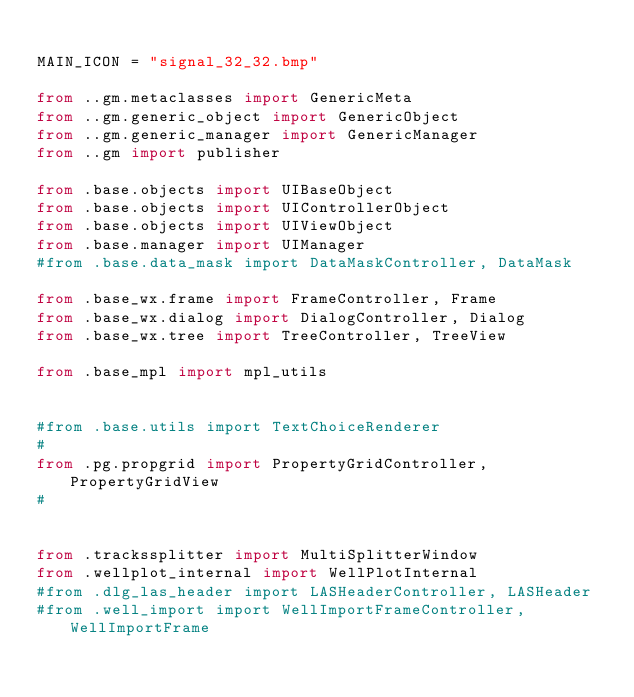<code> <loc_0><loc_0><loc_500><loc_500><_Python_>
MAIN_ICON = "signal_32_32.bmp"

from ..gm.metaclasses import GenericMeta
from ..gm.generic_object import GenericObject
from ..gm.generic_manager import GenericManager
from ..gm import publisher

from .base.objects import UIBaseObject
from .base.objects import UIControllerObject
from .base.objects import UIViewObject
from .base.manager import UIManager
#from .base.data_mask import DataMaskController, DataMask

from .base_wx.frame import FrameController, Frame
from .base_wx.dialog import DialogController, Dialog
from .base_wx.tree import TreeController, TreeView

from .base_mpl import mpl_utils
 

#from .base.utils import TextChoiceRenderer
#                                                
from .pg.propgrid import PropertyGridController, PropertyGridView
#


from .trackssplitter import MultiSplitterWindow
from .wellplot_internal import WellPlotInternal
#from .dlg_las_header import LASHeaderController, LASHeader
#from .well_import import WellImportFrameController, WellImportFrame
</code> 